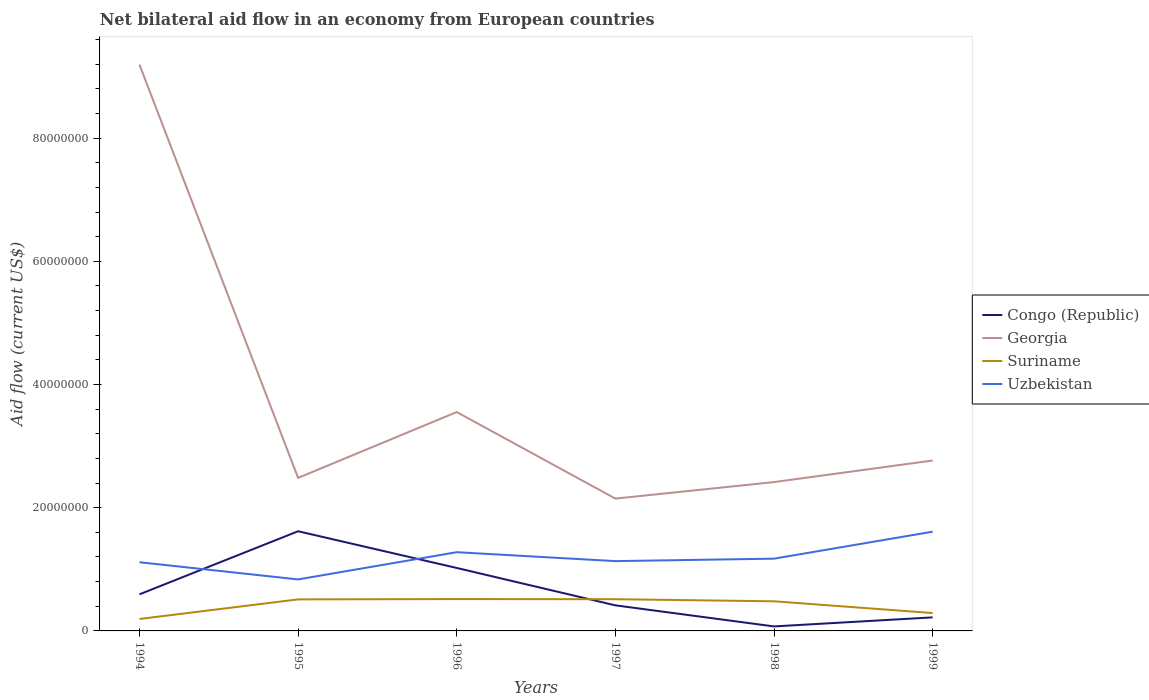Across all years, what is the maximum net bilateral aid flow in Uzbekistan?
Provide a succinct answer. 8.36e+06. What is the total net bilateral aid flow in Georgia in the graph?
Provide a succinct answer. 5.64e+07. What is the difference between the highest and the second highest net bilateral aid flow in Georgia?
Provide a succinct answer. 7.04e+07. What is the difference between the highest and the lowest net bilateral aid flow in Suriname?
Your response must be concise. 4. Where does the legend appear in the graph?
Offer a terse response. Center right. How many legend labels are there?
Give a very brief answer. 4. What is the title of the graph?
Provide a succinct answer. Net bilateral aid flow in an economy from European countries. Does "Argentina" appear as one of the legend labels in the graph?
Your response must be concise. No. What is the Aid flow (current US$) in Congo (Republic) in 1994?
Give a very brief answer. 5.94e+06. What is the Aid flow (current US$) of Georgia in 1994?
Offer a terse response. 9.19e+07. What is the Aid flow (current US$) of Suriname in 1994?
Your response must be concise. 1.94e+06. What is the Aid flow (current US$) of Uzbekistan in 1994?
Keep it short and to the point. 1.12e+07. What is the Aid flow (current US$) of Congo (Republic) in 1995?
Give a very brief answer. 1.62e+07. What is the Aid flow (current US$) of Georgia in 1995?
Ensure brevity in your answer.  2.48e+07. What is the Aid flow (current US$) of Suriname in 1995?
Ensure brevity in your answer.  5.12e+06. What is the Aid flow (current US$) of Uzbekistan in 1995?
Provide a succinct answer. 8.36e+06. What is the Aid flow (current US$) of Congo (Republic) in 1996?
Your answer should be very brief. 1.02e+07. What is the Aid flow (current US$) in Georgia in 1996?
Give a very brief answer. 3.55e+07. What is the Aid flow (current US$) of Suriname in 1996?
Ensure brevity in your answer.  5.17e+06. What is the Aid flow (current US$) in Uzbekistan in 1996?
Provide a succinct answer. 1.28e+07. What is the Aid flow (current US$) of Congo (Republic) in 1997?
Keep it short and to the point. 4.15e+06. What is the Aid flow (current US$) in Georgia in 1997?
Your answer should be very brief. 2.15e+07. What is the Aid flow (current US$) in Suriname in 1997?
Your response must be concise. 5.15e+06. What is the Aid flow (current US$) in Uzbekistan in 1997?
Make the answer very short. 1.13e+07. What is the Aid flow (current US$) in Congo (Republic) in 1998?
Offer a terse response. 7.30e+05. What is the Aid flow (current US$) of Georgia in 1998?
Offer a very short reply. 2.42e+07. What is the Aid flow (current US$) in Suriname in 1998?
Your answer should be compact. 4.81e+06. What is the Aid flow (current US$) of Uzbekistan in 1998?
Ensure brevity in your answer.  1.17e+07. What is the Aid flow (current US$) of Congo (Republic) in 1999?
Keep it short and to the point. 2.20e+06. What is the Aid flow (current US$) in Georgia in 1999?
Offer a very short reply. 2.77e+07. What is the Aid flow (current US$) in Suriname in 1999?
Provide a succinct answer. 2.90e+06. What is the Aid flow (current US$) of Uzbekistan in 1999?
Make the answer very short. 1.61e+07. Across all years, what is the maximum Aid flow (current US$) in Congo (Republic)?
Give a very brief answer. 1.62e+07. Across all years, what is the maximum Aid flow (current US$) of Georgia?
Offer a very short reply. 9.19e+07. Across all years, what is the maximum Aid flow (current US$) of Suriname?
Your response must be concise. 5.17e+06. Across all years, what is the maximum Aid flow (current US$) of Uzbekistan?
Offer a terse response. 1.61e+07. Across all years, what is the minimum Aid flow (current US$) in Congo (Republic)?
Offer a very short reply. 7.30e+05. Across all years, what is the minimum Aid flow (current US$) in Georgia?
Provide a short and direct response. 2.15e+07. Across all years, what is the minimum Aid flow (current US$) in Suriname?
Provide a short and direct response. 1.94e+06. Across all years, what is the minimum Aid flow (current US$) of Uzbekistan?
Keep it short and to the point. 8.36e+06. What is the total Aid flow (current US$) in Congo (Republic) in the graph?
Ensure brevity in your answer.  3.94e+07. What is the total Aid flow (current US$) of Georgia in the graph?
Offer a terse response. 2.26e+08. What is the total Aid flow (current US$) of Suriname in the graph?
Your answer should be very brief. 2.51e+07. What is the total Aid flow (current US$) of Uzbekistan in the graph?
Provide a succinct answer. 7.15e+07. What is the difference between the Aid flow (current US$) of Congo (Republic) in 1994 and that in 1995?
Make the answer very short. -1.02e+07. What is the difference between the Aid flow (current US$) of Georgia in 1994 and that in 1995?
Your response must be concise. 6.71e+07. What is the difference between the Aid flow (current US$) in Suriname in 1994 and that in 1995?
Provide a succinct answer. -3.18e+06. What is the difference between the Aid flow (current US$) of Uzbekistan in 1994 and that in 1995?
Make the answer very short. 2.79e+06. What is the difference between the Aid flow (current US$) in Congo (Republic) in 1994 and that in 1996?
Offer a terse response. -4.28e+06. What is the difference between the Aid flow (current US$) in Georgia in 1994 and that in 1996?
Offer a terse response. 5.64e+07. What is the difference between the Aid flow (current US$) in Suriname in 1994 and that in 1996?
Provide a short and direct response. -3.23e+06. What is the difference between the Aid flow (current US$) of Uzbekistan in 1994 and that in 1996?
Offer a very short reply. -1.63e+06. What is the difference between the Aid flow (current US$) of Congo (Republic) in 1994 and that in 1997?
Make the answer very short. 1.79e+06. What is the difference between the Aid flow (current US$) of Georgia in 1994 and that in 1997?
Offer a very short reply. 7.04e+07. What is the difference between the Aid flow (current US$) of Suriname in 1994 and that in 1997?
Provide a short and direct response. -3.21e+06. What is the difference between the Aid flow (current US$) in Uzbekistan in 1994 and that in 1997?
Provide a succinct answer. -1.80e+05. What is the difference between the Aid flow (current US$) of Congo (Republic) in 1994 and that in 1998?
Your response must be concise. 5.21e+06. What is the difference between the Aid flow (current US$) of Georgia in 1994 and that in 1998?
Your response must be concise. 6.78e+07. What is the difference between the Aid flow (current US$) of Suriname in 1994 and that in 1998?
Make the answer very short. -2.87e+06. What is the difference between the Aid flow (current US$) of Uzbekistan in 1994 and that in 1998?
Give a very brief answer. -5.80e+05. What is the difference between the Aid flow (current US$) of Congo (Republic) in 1994 and that in 1999?
Provide a succinct answer. 3.74e+06. What is the difference between the Aid flow (current US$) in Georgia in 1994 and that in 1999?
Your answer should be compact. 6.43e+07. What is the difference between the Aid flow (current US$) in Suriname in 1994 and that in 1999?
Give a very brief answer. -9.60e+05. What is the difference between the Aid flow (current US$) of Uzbekistan in 1994 and that in 1999?
Offer a terse response. -4.96e+06. What is the difference between the Aid flow (current US$) in Congo (Republic) in 1995 and that in 1996?
Give a very brief answer. 5.96e+06. What is the difference between the Aid flow (current US$) in Georgia in 1995 and that in 1996?
Ensure brevity in your answer.  -1.07e+07. What is the difference between the Aid flow (current US$) in Uzbekistan in 1995 and that in 1996?
Provide a short and direct response. -4.42e+06. What is the difference between the Aid flow (current US$) of Congo (Republic) in 1995 and that in 1997?
Ensure brevity in your answer.  1.20e+07. What is the difference between the Aid flow (current US$) in Georgia in 1995 and that in 1997?
Your response must be concise. 3.36e+06. What is the difference between the Aid flow (current US$) in Suriname in 1995 and that in 1997?
Keep it short and to the point. -3.00e+04. What is the difference between the Aid flow (current US$) of Uzbekistan in 1995 and that in 1997?
Keep it short and to the point. -2.97e+06. What is the difference between the Aid flow (current US$) of Congo (Republic) in 1995 and that in 1998?
Provide a short and direct response. 1.54e+07. What is the difference between the Aid flow (current US$) of Georgia in 1995 and that in 1998?
Ensure brevity in your answer.  6.80e+05. What is the difference between the Aid flow (current US$) in Uzbekistan in 1995 and that in 1998?
Your answer should be compact. -3.37e+06. What is the difference between the Aid flow (current US$) of Congo (Republic) in 1995 and that in 1999?
Your response must be concise. 1.40e+07. What is the difference between the Aid flow (current US$) in Georgia in 1995 and that in 1999?
Ensure brevity in your answer.  -2.82e+06. What is the difference between the Aid flow (current US$) in Suriname in 1995 and that in 1999?
Ensure brevity in your answer.  2.22e+06. What is the difference between the Aid flow (current US$) in Uzbekistan in 1995 and that in 1999?
Give a very brief answer. -7.75e+06. What is the difference between the Aid flow (current US$) in Congo (Republic) in 1996 and that in 1997?
Keep it short and to the point. 6.07e+06. What is the difference between the Aid flow (current US$) in Georgia in 1996 and that in 1997?
Provide a succinct answer. 1.40e+07. What is the difference between the Aid flow (current US$) of Suriname in 1996 and that in 1997?
Give a very brief answer. 2.00e+04. What is the difference between the Aid flow (current US$) in Uzbekistan in 1996 and that in 1997?
Offer a terse response. 1.45e+06. What is the difference between the Aid flow (current US$) in Congo (Republic) in 1996 and that in 1998?
Make the answer very short. 9.49e+06. What is the difference between the Aid flow (current US$) in Georgia in 1996 and that in 1998?
Provide a succinct answer. 1.14e+07. What is the difference between the Aid flow (current US$) of Uzbekistan in 1996 and that in 1998?
Your answer should be very brief. 1.05e+06. What is the difference between the Aid flow (current US$) in Congo (Republic) in 1996 and that in 1999?
Offer a very short reply. 8.02e+06. What is the difference between the Aid flow (current US$) of Georgia in 1996 and that in 1999?
Give a very brief answer. 7.87e+06. What is the difference between the Aid flow (current US$) in Suriname in 1996 and that in 1999?
Give a very brief answer. 2.27e+06. What is the difference between the Aid flow (current US$) of Uzbekistan in 1996 and that in 1999?
Make the answer very short. -3.33e+06. What is the difference between the Aid flow (current US$) of Congo (Republic) in 1997 and that in 1998?
Your answer should be compact. 3.42e+06. What is the difference between the Aid flow (current US$) of Georgia in 1997 and that in 1998?
Your answer should be compact. -2.68e+06. What is the difference between the Aid flow (current US$) in Suriname in 1997 and that in 1998?
Your answer should be very brief. 3.40e+05. What is the difference between the Aid flow (current US$) in Uzbekistan in 1997 and that in 1998?
Your answer should be compact. -4.00e+05. What is the difference between the Aid flow (current US$) of Congo (Republic) in 1997 and that in 1999?
Your answer should be very brief. 1.95e+06. What is the difference between the Aid flow (current US$) in Georgia in 1997 and that in 1999?
Offer a very short reply. -6.18e+06. What is the difference between the Aid flow (current US$) in Suriname in 1997 and that in 1999?
Your answer should be very brief. 2.25e+06. What is the difference between the Aid flow (current US$) in Uzbekistan in 1997 and that in 1999?
Provide a short and direct response. -4.78e+06. What is the difference between the Aid flow (current US$) of Congo (Republic) in 1998 and that in 1999?
Offer a very short reply. -1.47e+06. What is the difference between the Aid flow (current US$) of Georgia in 1998 and that in 1999?
Make the answer very short. -3.50e+06. What is the difference between the Aid flow (current US$) of Suriname in 1998 and that in 1999?
Keep it short and to the point. 1.91e+06. What is the difference between the Aid flow (current US$) in Uzbekistan in 1998 and that in 1999?
Provide a short and direct response. -4.38e+06. What is the difference between the Aid flow (current US$) of Congo (Republic) in 1994 and the Aid flow (current US$) of Georgia in 1995?
Keep it short and to the point. -1.89e+07. What is the difference between the Aid flow (current US$) of Congo (Republic) in 1994 and the Aid flow (current US$) of Suriname in 1995?
Provide a short and direct response. 8.20e+05. What is the difference between the Aid flow (current US$) in Congo (Republic) in 1994 and the Aid flow (current US$) in Uzbekistan in 1995?
Provide a succinct answer. -2.42e+06. What is the difference between the Aid flow (current US$) of Georgia in 1994 and the Aid flow (current US$) of Suriname in 1995?
Your response must be concise. 8.68e+07. What is the difference between the Aid flow (current US$) of Georgia in 1994 and the Aid flow (current US$) of Uzbekistan in 1995?
Give a very brief answer. 8.36e+07. What is the difference between the Aid flow (current US$) in Suriname in 1994 and the Aid flow (current US$) in Uzbekistan in 1995?
Provide a succinct answer. -6.42e+06. What is the difference between the Aid flow (current US$) in Congo (Republic) in 1994 and the Aid flow (current US$) in Georgia in 1996?
Offer a very short reply. -2.96e+07. What is the difference between the Aid flow (current US$) in Congo (Republic) in 1994 and the Aid flow (current US$) in Suriname in 1996?
Your answer should be compact. 7.70e+05. What is the difference between the Aid flow (current US$) in Congo (Republic) in 1994 and the Aid flow (current US$) in Uzbekistan in 1996?
Provide a short and direct response. -6.84e+06. What is the difference between the Aid flow (current US$) in Georgia in 1994 and the Aid flow (current US$) in Suriname in 1996?
Provide a succinct answer. 8.68e+07. What is the difference between the Aid flow (current US$) in Georgia in 1994 and the Aid flow (current US$) in Uzbekistan in 1996?
Give a very brief answer. 7.91e+07. What is the difference between the Aid flow (current US$) of Suriname in 1994 and the Aid flow (current US$) of Uzbekistan in 1996?
Your response must be concise. -1.08e+07. What is the difference between the Aid flow (current US$) of Congo (Republic) in 1994 and the Aid flow (current US$) of Georgia in 1997?
Keep it short and to the point. -1.55e+07. What is the difference between the Aid flow (current US$) of Congo (Republic) in 1994 and the Aid flow (current US$) of Suriname in 1997?
Provide a succinct answer. 7.90e+05. What is the difference between the Aid flow (current US$) in Congo (Republic) in 1994 and the Aid flow (current US$) in Uzbekistan in 1997?
Give a very brief answer. -5.39e+06. What is the difference between the Aid flow (current US$) in Georgia in 1994 and the Aid flow (current US$) in Suriname in 1997?
Make the answer very short. 8.68e+07. What is the difference between the Aid flow (current US$) in Georgia in 1994 and the Aid flow (current US$) in Uzbekistan in 1997?
Your answer should be very brief. 8.06e+07. What is the difference between the Aid flow (current US$) of Suriname in 1994 and the Aid flow (current US$) of Uzbekistan in 1997?
Provide a succinct answer. -9.39e+06. What is the difference between the Aid flow (current US$) of Congo (Republic) in 1994 and the Aid flow (current US$) of Georgia in 1998?
Give a very brief answer. -1.82e+07. What is the difference between the Aid flow (current US$) in Congo (Republic) in 1994 and the Aid flow (current US$) in Suriname in 1998?
Keep it short and to the point. 1.13e+06. What is the difference between the Aid flow (current US$) in Congo (Republic) in 1994 and the Aid flow (current US$) in Uzbekistan in 1998?
Your answer should be compact. -5.79e+06. What is the difference between the Aid flow (current US$) in Georgia in 1994 and the Aid flow (current US$) in Suriname in 1998?
Make the answer very short. 8.71e+07. What is the difference between the Aid flow (current US$) of Georgia in 1994 and the Aid flow (current US$) of Uzbekistan in 1998?
Your response must be concise. 8.02e+07. What is the difference between the Aid flow (current US$) in Suriname in 1994 and the Aid flow (current US$) in Uzbekistan in 1998?
Ensure brevity in your answer.  -9.79e+06. What is the difference between the Aid flow (current US$) in Congo (Republic) in 1994 and the Aid flow (current US$) in Georgia in 1999?
Your response must be concise. -2.17e+07. What is the difference between the Aid flow (current US$) of Congo (Republic) in 1994 and the Aid flow (current US$) of Suriname in 1999?
Give a very brief answer. 3.04e+06. What is the difference between the Aid flow (current US$) in Congo (Republic) in 1994 and the Aid flow (current US$) in Uzbekistan in 1999?
Offer a terse response. -1.02e+07. What is the difference between the Aid flow (current US$) of Georgia in 1994 and the Aid flow (current US$) of Suriname in 1999?
Your response must be concise. 8.90e+07. What is the difference between the Aid flow (current US$) of Georgia in 1994 and the Aid flow (current US$) of Uzbekistan in 1999?
Your answer should be very brief. 7.58e+07. What is the difference between the Aid flow (current US$) in Suriname in 1994 and the Aid flow (current US$) in Uzbekistan in 1999?
Provide a short and direct response. -1.42e+07. What is the difference between the Aid flow (current US$) of Congo (Republic) in 1995 and the Aid flow (current US$) of Georgia in 1996?
Provide a succinct answer. -1.94e+07. What is the difference between the Aid flow (current US$) in Congo (Republic) in 1995 and the Aid flow (current US$) in Suriname in 1996?
Your answer should be compact. 1.10e+07. What is the difference between the Aid flow (current US$) of Congo (Republic) in 1995 and the Aid flow (current US$) of Uzbekistan in 1996?
Your answer should be compact. 3.40e+06. What is the difference between the Aid flow (current US$) in Georgia in 1995 and the Aid flow (current US$) in Suriname in 1996?
Provide a succinct answer. 1.97e+07. What is the difference between the Aid flow (current US$) of Georgia in 1995 and the Aid flow (current US$) of Uzbekistan in 1996?
Offer a terse response. 1.21e+07. What is the difference between the Aid flow (current US$) in Suriname in 1995 and the Aid flow (current US$) in Uzbekistan in 1996?
Provide a succinct answer. -7.66e+06. What is the difference between the Aid flow (current US$) in Congo (Republic) in 1995 and the Aid flow (current US$) in Georgia in 1997?
Offer a terse response. -5.30e+06. What is the difference between the Aid flow (current US$) of Congo (Republic) in 1995 and the Aid flow (current US$) of Suriname in 1997?
Give a very brief answer. 1.10e+07. What is the difference between the Aid flow (current US$) of Congo (Republic) in 1995 and the Aid flow (current US$) of Uzbekistan in 1997?
Ensure brevity in your answer.  4.85e+06. What is the difference between the Aid flow (current US$) of Georgia in 1995 and the Aid flow (current US$) of Suriname in 1997?
Ensure brevity in your answer.  1.97e+07. What is the difference between the Aid flow (current US$) of Georgia in 1995 and the Aid flow (current US$) of Uzbekistan in 1997?
Your answer should be very brief. 1.35e+07. What is the difference between the Aid flow (current US$) in Suriname in 1995 and the Aid flow (current US$) in Uzbekistan in 1997?
Keep it short and to the point. -6.21e+06. What is the difference between the Aid flow (current US$) in Congo (Republic) in 1995 and the Aid flow (current US$) in Georgia in 1998?
Ensure brevity in your answer.  -7.98e+06. What is the difference between the Aid flow (current US$) of Congo (Republic) in 1995 and the Aid flow (current US$) of Suriname in 1998?
Give a very brief answer. 1.14e+07. What is the difference between the Aid flow (current US$) of Congo (Republic) in 1995 and the Aid flow (current US$) of Uzbekistan in 1998?
Your answer should be compact. 4.45e+06. What is the difference between the Aid flow (current US$) of Georgia in 1995 and the Aid flow (current US$) of Suriname in 1998?
Provide a short and direct response. 2.00e+07. What is the difference between the Aid flow (current US$) in Georgia in 1995 and the Aid flow (current US$) in Uzbekistan in 1998?
Your response must be concise. 1.31e+07. What is the difference between the Aid flow (current US$) in Suriname in 1995 and the Aid flow (current US$) in Uzbekistan in 1998?
Provide a short and direct response. -6.61e+06. What is the difference between the Aid flow (current US$) of Congo (Republic) in 1995 and the Aid flow (current US$) of Georgia in 1999?
Keep it short and to the point. -1.15e+07. What is the difference between the Aid flow (current US$) of Congo (Republic) in 1995 and the Aid flow (current US$) of Suriname in 1999?
Keep it short and to the point. 1.33e+07. What is the difference between the Aid flow (current US$) in Congo (Republic) in 1995 and the Aid flow (current US$) in Uzbekistan in 1999?
Keep it short and to the point. 7.00e+04. What is the difference between the Aid flow (current US$) of Georgia in 1995 and the Aid flow (current US$) of Suriname in 1999?
Your answer should be compact. 2.19e+07. What is the difference between the Aid flow (current US$) in Georgia in 1995 and the Aid flow (current US$) in Uzbekistan in 1999?
Make the answer very short. 8.73e+06. What is the difference between the Aid flow (current US$) of Suriname in 1995 and the Aid flow (current US$) of Uzbekistan in 1999?
Provide a short and direct response. -1.10e+07. What is the difference between the Aid flow (current US$) of Congo (Republic) in 1996 and the Aid flow (current US$) of Georgia in 1997?
Ensure brevity in your answer.  -1.13e+07. What is the difference between the Aid flow (current US$) in Congo (Republic) in 1996 and the Aid flow (current US$) in Suriname in 1997?
Give a very brief answer. 5.07e+06. What is the difference between the Aid flow (current US$) in Congo (Republic) in 1996 and the Aid flow (current US$) in Uzbekistan in 1997?
Your answer should be very brief. -1.11e+06. What is the difference between the Aid flow (current US$) in Georgia in 1996 and the Aid flow (current US$) in Suriname in 1997?
Your answer should be compact. 3.04e+07. What is the difference between the Aid flow (current US$) of Georgia in 1996 and the Aid flow (current US$) of Uzbekistan in 1997?
Your answer should be very brief. 2.42e+07. What is the difference between the Aid flow (current US$) of Suriname in 1996 and the Aid flow (current US$) of Uzbekistan in 1997?
Keep it short and to the point. -6.16e+06. What is the difference between the Aid flow (current US$) in Congo (Republic) in 1996 and the Aid flow (current US$) in Georgia in 1998?
Provide a short and direct response. -1.39e+07. What is the difference between the Aid flow (current US$) of Congo (Republic) in 1996 and the Aid flow (current US$) of Suriname in 1998?
Provide a succinct answer. 5.41e+06. What is the difference between the Aid flow (current US$) in Congo (Republic) in 1996 and the Aid flow (current US$) in Uzbekistan in 1998?
Your response must be concise. -1.51e+06. What is the difference between the Aid flow (current US$) in Georgia in 1996 and the Aid flow (current US$) in Suriname in 1998?
Your response must be concise. 3.07e+07. What is the difference between the Aid flow (current US$) of Georgia in 1996 and the Aid flow (current US$) of Uzbekistan in 1998?
Offer a very short reply. 2.38e+07. What is the difference between the Aid flow (current US$) of Suriname in 1996 and the Aid flow (current US$) of Uzbekistan in 1998?
Your answer should be compact. -6.56e+06. What is the difference between the Aid flow (current US$) in Congo (Republic) in 1996 and the Aid flow (current US$) in Georgia in 1999?
Provide a succinct answer. -1.74e+07. What is the difference between the Aid flow (current US$) in Congo (Republic) in 1996 and the Aid flow (current US$) in Suriname in 1999?
Ensure brevity in your answer.  7.32e+06. What is the difference between the Aid flow (current US$) in Congo (Republic) in 1996 and the Aid flow (current US$) in Uzbekistan in 1999?
Make the answer very short. -5.89e+06. What is the difference between the Aid flow (current US$) in Georgia in 1996 and the Aid flow (current US$) in Suriname in 1999?
Provide a succinct answer. 3.26e+07. What is the difference between the Aid flow (current US$) in Georgia in 1996 and the Aid flow (current US$) in Uzbekistan in 1999?
Offer a terse response. 1.94e+07. What is the difference between the Aid flow (current US$) of Suriname in 1996 and the Aid flow (current US$) of Uzbekistan in 1999?
Ensure brevity in your answer.  -1.09e+07. What is the difference between the Aid flow (current US$) of Congo (Republic) in 1997 and the Aid flow (current US$) of Georgia in 1998?
Offer a very short reply. -2.00e+07. What is the difference between the Aid flow (current US$) in Congo (Republic) in 1997 and the Aid flow (current US$) in Suriname in 1998?
Your response must be concise. -6.60e+05. What is the difference between the Aid flow (current US$) of Congo (Republic) in 1997 and the Aid flow (current US$) of Uzbekistan in 1998?
Make the answer very short. -7.58e+06. What is the difference between the Aid flow (current US$) in Georgia in 1997 and the Aid flow (current US$) in Suriname in 1998?
Your response must be concise. 1.67e+07. What is the difference between the Aid flow (current US$) of Georgia in 1997 and the Aid flow (current US$) of Uzbekistan in 1998?
Offer a terse response. 9.75e+06. What is the difference between the Aid flow (current US$) of Suriname in 1997 and the Aid flow (current US$) of Uzbekistan in 1998?
Make the answer very short. -6.58e+06. What is the difference between the Aid flow (current US$) of Congo (Republic) in 1997 and the Aid flow (current US$) of Georgia in 1999?
Your answer should be compact. -2.35e+07. What is the difference between the Aid flow (current US$) of Congo (Republic) in 1997 and the Aid flow (current US$) of Suriname in 1999?
Keep it short and to the point. 1.25e+06. What is the difference between the Aid flow (current US$) of Congo (Republic) in 1997 and the Aid flow (current US$) of Uzbekistan in 1999?
Provide a succinct answer. -1.20e+07. What is the difference between the Aid flow (current US$) of Georgia in 1997 and the Aid flow (current US$) of Suriname in 1999?
Offer a terse response. 1.86e+07. What is the difference between the Aid flow (current US$) of Georgia in 1997 and the Aid flow (current US$) of Uzbekistan in 1999?
Ensure brevity in your answer.  5.37e+06. What is the difference between the Aid flow (current US$) in Suriname in 1997 and the Aid flow (current US$) in Uzbekistan in 1999?
Make the answer very short. -1.10e+07. What is the difference between the Aid flow (current US$) of Congo (Republic) in 1998 and the Aid flow (current US$) of Georgia in 1999?
Offer a terse response. -2.69e+07. What is the difference between the Aid flow (current US$) in Congo (Republic) in 1998 and the Aid flow (current US$) in Suriname in 1999?
Offer a very short reply. -2.17e+06. What is the difference between the Aid flow (current US$) in Congo (Republic) in 1998 and the Aid flow (current US$) in Uzbekistan in 1999?
Your response must be concise. -1.54e+07. What is the difference between the Aid flow (current US$) in Georgia in 1998 and the Aid flow (current US$) in Suriname in 1999?
Offer a very short reply. 2.13e+07. What is the difference between the Aid flow (current US$) of Georgia in 1998 and the Aid flow (current US$) of Uzbekistan in 1999?
Your answer should be compact. 8.05e+06. What is the difference between the Aid flow (current US$) in Suriname in 1998 and the Aid flow (current US$) in Uzbekistan in 1999?
Your answer should be compact. -1.13e+07. What is the average Aid flow (current US$) of Congo (Republic) per year?
Keep it short and to the point. 6.57e+06. What is the average Aid flow (current US$) in Georgia per year?
Ensure brevity in your answer.  3.76e+07. What is the average Aid flow (current US$) of Suriname per year?
Provide a succinct answer. 4.18e+06. What is the average Aid flow (current US$) in Uzbekistan per year?
Keep it short and to the point. 1.19e+07. In the year 1994, what is the difference between the Aid flow (current US$) in Congo (Republic) and Aid flow (current US$) in Georgia?
Your answer should be compact. -8.60e+07. In the year 1994, what is the difference between the Aid flow (current US$) in Congo (Republic) and Aid flow (current US$) in Suriname?
Give a very brief answer. 4.00e+06. In the year 1994, what is the difference between the Aid flow (current US$) in Congo (Republic) and Aid flow (current US$) in Uzbekistan?
Offer a very short reply. -5.21e+06. In the year 1994, what is the difference between the Aid flow (current US$) of Georgia and Aid flow (current US$) of Suriname?
Your response must be concise. 9.00e+07. In the year 1994, what is the difference between the Aid flow (current US$) in Georgia and Aid flow (current US$) in Uzbekistan?
Ensure brevity in your answer.  8.08e+07. In the year 1994, what is the difference between the Aid flow (current US$) of Suriname and Aid flow (current US$) of Uzbekistan?
Your answer should be compact. -9.21e+06. In the year 1995, what is the difference between the Aid flow (current US$) of Congo (Republic) and Aid flow (current US$) of Georgia?
Give a very brief answer. -8.66e+06. In the year 1995, what is the difference between the Aid flow (current US$) of Congo (Republic) and Aid flow (current US$) of Suriname?
Provide a short and direct response. 1.11e+07. In the year 1995, what is the difference between the Aid flow (current US$) of Congo (Republic) and Aid flow (current US$) of Uzbekistan?
Provide a succinct answer. 7.82e+06. In the year 1995, what is the difference between the Aid flow (current US$) in Georgia and Aid flow (current US$) in Suriname?
Make the answer very short. 1.97e+07. In the year 1995, what is the difference between the Aid flow (current US$) in Georgia and Aid flow (current US$) in Uzbekistan?
Provide a short and direct response. 1.65e+07. In the year 1995, what is the difference between the Aid flow (current US$) in Suriname and Aid flow (current US$) in Uzbekistan?
Your answer should be very brief. -3.24e+06. In the year 1996, what is the difference between the Aid flow (current US$) in Congo (Republic) and Aid flow (current US$) in Georgia?
Keep it short and to the point. -2.53e+07. In the year 1996, what is the difference between the Aid flow (current US$) in Congo (Republic) and Aid flow (current US$) in Suriname?
Provide a short and direct response. 5.05e+06. In the year 1996, what is the difference between the Aid flow (current US$) of Congo (Republic) and Aid flow (current US$) of Uzbekistan?
Give a very brief answer. -2.56e+06. In the year 1996, what is the difference between the Aid flow (current US$) of Georgia and Aid flow (current US$) of Suriname?
Provide a short and direct response. 3.04e+07. In the year 1996, what is the difference between the Aid flow (current US$) in Georgia and Aid flow (current US$) in Uzbekistan?
Keep it short and to the point. 2.28e+07. In the year 1996, what is the difference between the Aid flow (current US$) in Suriname and Aid flow (current US$) in Uzbekistan?
Your response must be concise. -7.61e+06. In the year 1997, what is the difference between the Aid flow (current US$) in Congo (Republic) and Aid flow (current US$) in Georgia?
Your answer should be very brief. -1.73e+07. In the year 1997, what is the difference between the Aid flow (current US$) in Congo (Republic) and Aid flow (current US$) in Suriname?
Provide a short and direct response. -1.00e+06. In the year 1997, what is the difference between the Aid flow (current US$) in Congo (Republic) and Aid flow (current US$) in Uzbekistan?
Your answer should be very brief. -7.18e+06. In the year 1997, what is the difference between the Aid flow (current US$) in Georgia and Aid flow (current US$) in Suriname?
Your answer should be very brief. 1.63e+07. In the year 1997, what is the difference between the Aid flow (current US$) in Georgia and Aid flow (current US$) in Uzbekistan?
Offer a very short reply. 1.02e+07. In the year 1997, what is the difference between the Aid flow (current US$) in Suriname and Aid flow (current US$) in Uzbekistan?
Offer a terse response. -6.18e+06. In the year 1998, what is the difference between the Aid flow (current US$) in Congo (Republic) and Aid flow (current US$) in Georgia?
Make the answer very short. -2.34e+07. In the year 1998, what is the difference between the Aid flow (current US$) in Congo (Republic) and Aid flow (current US$) in Suriname?
Ensure brevity in your answer.  -4.08e+06. In the year 1998, what is the difference between the Aid flow (current US$) in Congo (Republic) and Aid flow (current US$) in Uzbekistan?
Provide a short and direct response. -1.10e+07. In the year 1998, what is the difference between the Aid flow (current US$) in Georgia and Aid flow (current US$) in Suriname?
Offer a terse response. 1.94e+07. In the year 1998, what is the difference between the Aid flow (current US$) in Georgia and Aid flow (current US$) in Uzbekistan?
Offer a very short reply. 1.24e+07. In the year 1998, what is the difference between the Aid flow (current US$) of Suriname and Aid flow (current US$) of Uzbekistan?
Keep it short and to the point. -6.92e+06. In the year 1999, what is the difference between the Aid flow (current US$) in Congo (Republic) and Aid flow (current US$) in Georgia?
Keep it short and to the point. -2.55e+07. In the year 1999, what is the difference between the Aid flow (current US$) of Congo (Republic) and Aid flow (current US$) of Suriname?
Offer a terse response. -7.00e+05. In the year 1999, what is the difference between the Aid flow (current US$) of Congo (Republic) and Aid flow (current US$) of Uzbekistan?
Your answer should be very brief. -1.39e+07. In the year 1999, what is the difference between the Aid flow (current US$) in Georgia and Aid flow (current US$) in Suriname?
Provide a succinct answer. 2.48e+07. In the year 1999, what is the difference between the Aid flow (current US$) in Georgia and Aid flow (current US$) in Uzbekistan?
Provide a succinct answer. 1.16e+07. In the year 1999, what is the difference between the Aid flow (current US$) of Suriname and Aid flow (current US$) of Uzbekistan?
Offer a terse response. -1.32e+07. What is the ratio of the Aid flow (current US$) of Congo (Republic) in 1994 to that in 1995?
Provide a short and direct response. 0.37. What is the ratio of the Aid flow (current US$) of Georgia in 1994 to that in 1995?
Give a very brief answer. 3.7. What is the ratio of the Aid flow (current US$) in Suriname in 1994 to that in 1995?
Make the answer very short. 0.38. What is the ratio of the Aid flow (current US$) in Uzbekistan in 1994 to that in 1995?
Your answer should be very brief. 1.33. What is the ratio of the Aid flow (current US$) in Congo (Republic) in 1994 to that in 1996?
Provide a short and direct response. 0.58. What is the ratio of the Aid flow (current US$) of Georgia in 1994 to that in 1996?
Keep it short and to the point. 2.59. What is the ratio of the Aid flow (current US$) in Suriname in 1994 to that in 1996?
Give a very brief answer. 0.38. What is the ratio of the Aid flow (current US$) of Uzbekistan in 1994 to that in 1996?
Offer a very short reply. 0.87. What is the ratio of the Aid flow (current US$) in Congo (Republic) in 1994 to that in 1997?
Offer a very short reply. 1.43. What is the ratio of the Aid flow (current US$) of Georgia in 1994 to that in 1997?
Ensure brevity in your answer.  4.28. What is the ratio of the Aid flow (current US$) of Suriname in 1994 to that in 1997?
Provide a short and direct response. 0.38. What is the ratio of the Aid flow (current US$) in Uzbekistan in 1994 to that in 1997?
Your answer should be very brief. 0.98. What is the ratio of the Aid flow (current US$) in Congo (Republic) in 1994 to that in 1998?
Make the answer very short. 8.14. What is the ratio of the Aid flow (current US$) in Georgia in 1994 to that in 1998?
Your answer should be very brief. 3.8. What is the ratio of the Aid flow (current US$) of Suriname in 1994 to that in 1998?
Your answer should be compact. 0.4. What is the ratio of the Aid flow (current US$) in Uzbekistan in 1994 to that in 1998?
Your response must be concise. 0.95. What is the ratio of the Aid flow (current US$) of Georgia in 1994 to that in 1999?
Your answer should be compact. 3.32. What is the ratio of the Aid flow (current US$) in Suriname in 1994 to that in 1999?
Make the answer very short. 0.67. What is the ratio of the Aid flow (current US$) of Uzbekistan in 1994 to that in 1999?
Keep it short and to the point. 0.69. What is the ratio of the Aid flow (current US$) of Congo (Republic) in 1995 to that in 1996?
Make the answer very short. 1.58. What is the ratio of the Aid flow (current US$) of Georgia in 1995 to that in 1996?
Ensure brevity in your answer.  0.7. What is the ratio of the Aid flow (current US$) of Suriname in 1995 to that in 1996?
Offer a very short reply. 0.99. What is the ratio of the Aid flow (current US$) in Uzbekistan in 1995 to that in 1996?
Offer a very short reply. 0.65. What is the ratio of the Aid flow (current US$) in Congo (Republic) in 1995 to that in 1997?
Provide a succinct answer. 3.9. What is the ratio of the Aid flow (current US$) of Georgia in 1995 to that in 1997?
Make the answer very short. 1.16. What is the ratio of the Aid flow (current US$) of Suriname in 1995 to that in 1997?
Provide a succinct answer. 0.99. What is the ratio of the Aid flow (current US$) in Uzbekistan in 1995 to that in 1997?
Ensure brevity in your answer.  0.74. What is the ratio of the Aid flow (current US$) of Congo (Republic) in 1995 to that in 1998?
Keep it short and to the point. 22.16. What is the ratio of the Aid flow (current US$) of Georgia in 1995 to that in 1998?
Provide a succinct answer. 1.03. What is the ratio of the Aid flow (current US$) in Suriname in 1995 to that in 1998?
Provide a short and direct response. 1.06. What is the ratio of the Aid flow (current US$) in Uzbekistan in 1995 to that in 1998?
Ensure brevity in your answer.  0.71. What is the ratio of the Aid flow (current US$) in Congo (Republic) in 1995 to that in 1999?
Offer a very short reply. 7.35. What is the ratio of the Aid flow (current US$) in Georgia in 1995 to that in 1999?
Offer a terse response. 0.9. What is the ratio of the Aid flow (current US$) in Suriname in 1995 to that in 1999?
Ensure brevity in your answer.  1.77. What is the ratio of the Aid flow (current US$) of Uzbekistan in 1995 to that in 1999?
Offer a very short reply. 0.52. What is the ratio of the Aid flow (current US$) in Congo (Republic) in 1996 to that in 1997?
Offer a very short reply. 2.46. What is the ratio of the Aid flow (current US$) of Georgia in 1996 to that in 1997?
Ensure brevity in your answer.  1.65. What is the ratio of the Aid flow (current US$) in Suriname in 1996 to that in 1997?
Ensure brevity in your answer.  1. What is the ratio of the Aid flow (current US$) of Uzbekistan in 1996 to that in 1997?
Offer a terse response. 1.13. What is the ratio of the Aid flow (current US$) in Georgia in 1996 to that in 1998?
Offer a terse response. 1.47. What is the ratio of the Aid flow (current US$) of Suriname in 1996 to that in 1998?
Provide a succinct answer. 1.07. What is the ratio of the Aid flow (current US$) of Uzbekistan in 1996 to that in 1998?
Give a very brief answer. 1.09. What is the ratio of the Aid flow (current US$) of Congo (Republic) in 1996 to that in 1999?
Provide a succinct answer. 4.65. What is the ratio of the Aid flow (current US$) in Georgia in 1996 to that in 1999?
Offer a terse response. 1.28. What is the ratio of the Aid flow (current US$) of Suriname in 1996 to that in 1999?
Keep it short and to the point. 1.78. What is the ratio of the Aid flow (current US$) of Uzbekistan in 1996 to that in 1999?
Your answer should be very brief. 0.79. What is the ratio of the Aid flow (current US$) in Congo (Republic) in 1997 to that in 1998?
Your answer should be compact. 5.68. What is the ratio of the Aid flow (current US$) of Georgia in 1997 to that in 1998?
Your answer should be very brief. 0.89. What is the ratio of the Aid flow (current US$) in Suriname in 1997 to that in 1998?
Your response must be concise. 1.07. What is the ratio of the Aid flow (current US$) in Uzbekistan in 1997 to that in 1998?
Make the answer very short. 0.97. What is the ratio of the Aid flow (current US$) of Congo (Republic) in 1997 to that in 1999?
Offer a terse response. 1.89. What is the ratio of the Aid flow (current US$) in Georgia in 1997 to that in 1999?
Provide a succinct answer. 0.78. What is the ratio of the Aid flow (current US$) of Suriname in 1997 to that in 1999?
Provide a short and direct response. 1.78. What is the ratio of the Aid flow (current US$) in Uzbekistan in 1997 to that in 1999?
Give a very brief answer. 0.7. What is the ratio of the Aid flow (current US$) of Congo (Republic) in 1998 to that in 1999?
Your answer should be compact. 0.33. What is the ratio of the Aid flow (current US$) of Georgia in 1998 to that in 1999?
Provide a succinct answer. 0.87. What is the ratio of the Aid flow (current US$) of Suriname in 1998 to that in 1999?
Provide a short and direct response. 1.66. What is the ratio of the Aid flow (current US$) in Uzbekistan in 1998 to that in 1999?
Offer a terse response. 0.73. What is the difference between the highest and the second highest Aid flow (current US$) of Congo (Republic)?
Offer a terse response. 5.96e+06. What is the difference between the highest and the second highest Aid flow (current US$) in Georgia?
Make the answer very short. 5.64e+07. What is the difference between the highest and the second highest Aid flow (current US$) of Uzbekistan?
Provide a short and direct response. 3.33e+06. What is the difference between the highest and the lowest Aid flow (current US$) in Congo (Republic)?
Offer a very short reply. 1.54e+07. What is the difference between the highest and the lowest Aid flow (current US$) of Georgia?
Your answer should be very brief. 7.04e+07. What is the difference between the highest and the lowest Aid flow (current US$) in Suriname?
Ensure brevity in your answer.  3.23e+06. What is the difference between the highest and the lowest Aid flow (current US$) in Uzbekistan?
Make the answer very short. 7.75e+06. 